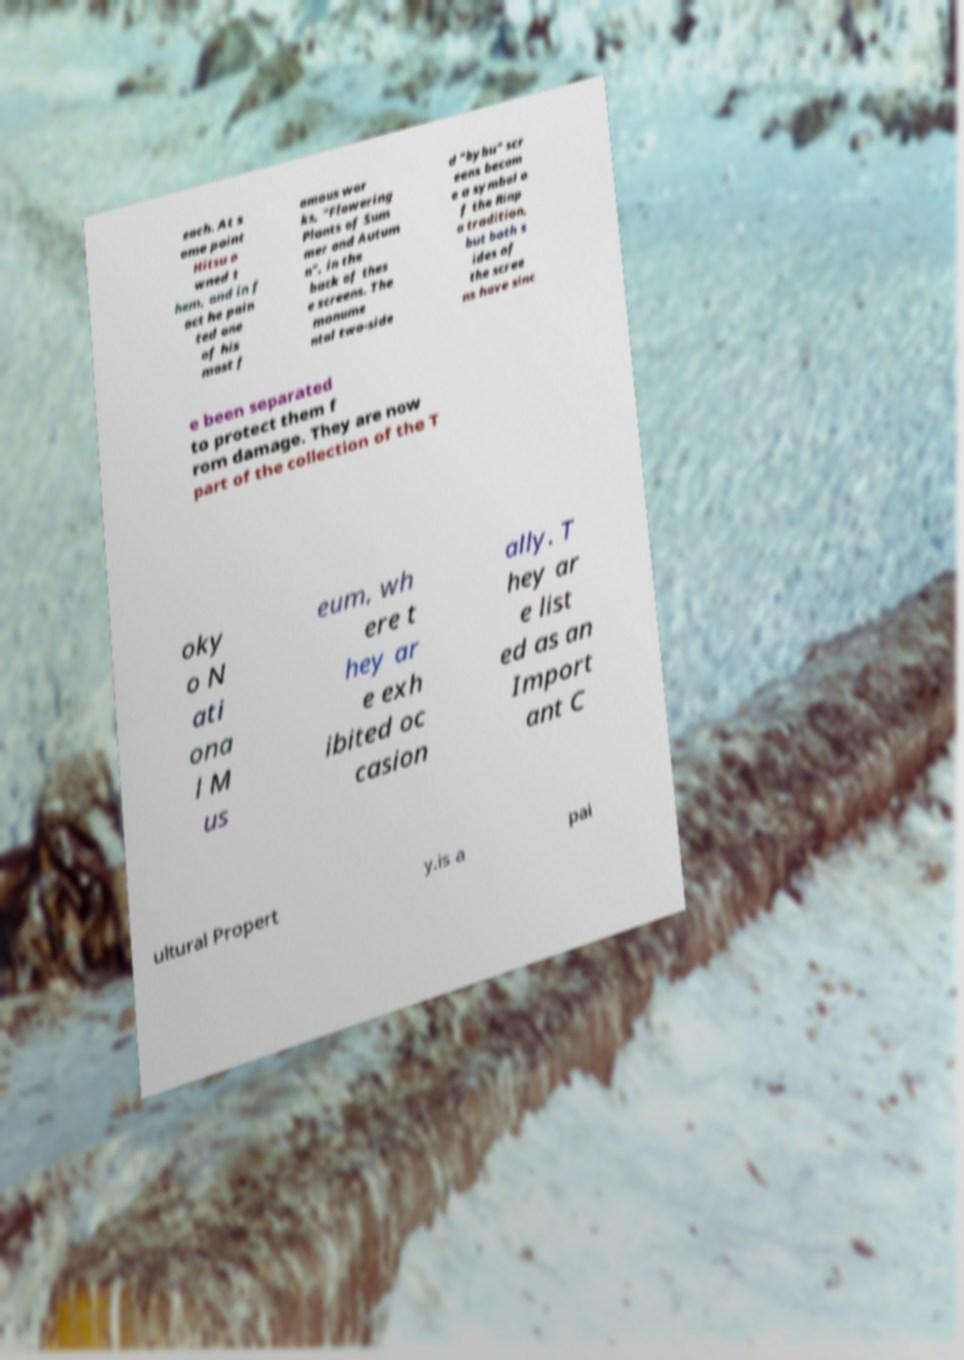There's text embedded in this image that I need extracted. Can you transcribe it verbatim? each. At s ome point Hitsu o wned t hem, and in f act he pain ted one of his most f amous wor ks, "Flowering Plants of Sum mer and Autum n", in the back of thes e screens. The monume ntal two-side d "bybu" scr eens becam e a symbol o f the Rinp a tradition, but both s ides of the scree ns have sinc e been separated to protect them f rom damage. They are now part of the collection of the T oky o N ati ona l M us eum, wh ere t hey ar e exh ibited oc casion ally. T hey ar e list ed as an Import ant C ultural Propert y.is a pai 